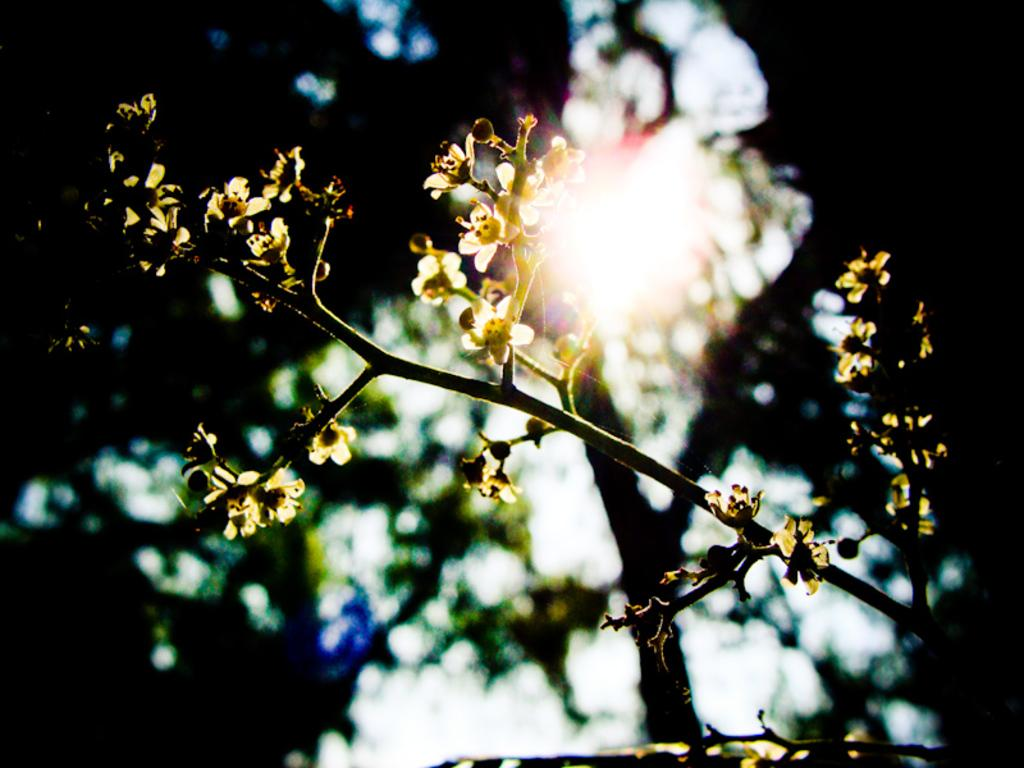What type of plant is present in the image? There are flowers on a plant in the image. What can be seen in the background of the image? There is a tree visible in the background of the image. What is visible at the top of the image? The sky is visible at the top of the image. Can the sun be seen in the sky? Yes, the sun is observable in the sky. What type of loaf is being baked in the image? There is no loaf present in the image; it features a plant with flowers, a tree in the background, and a sky with the sun visible. 